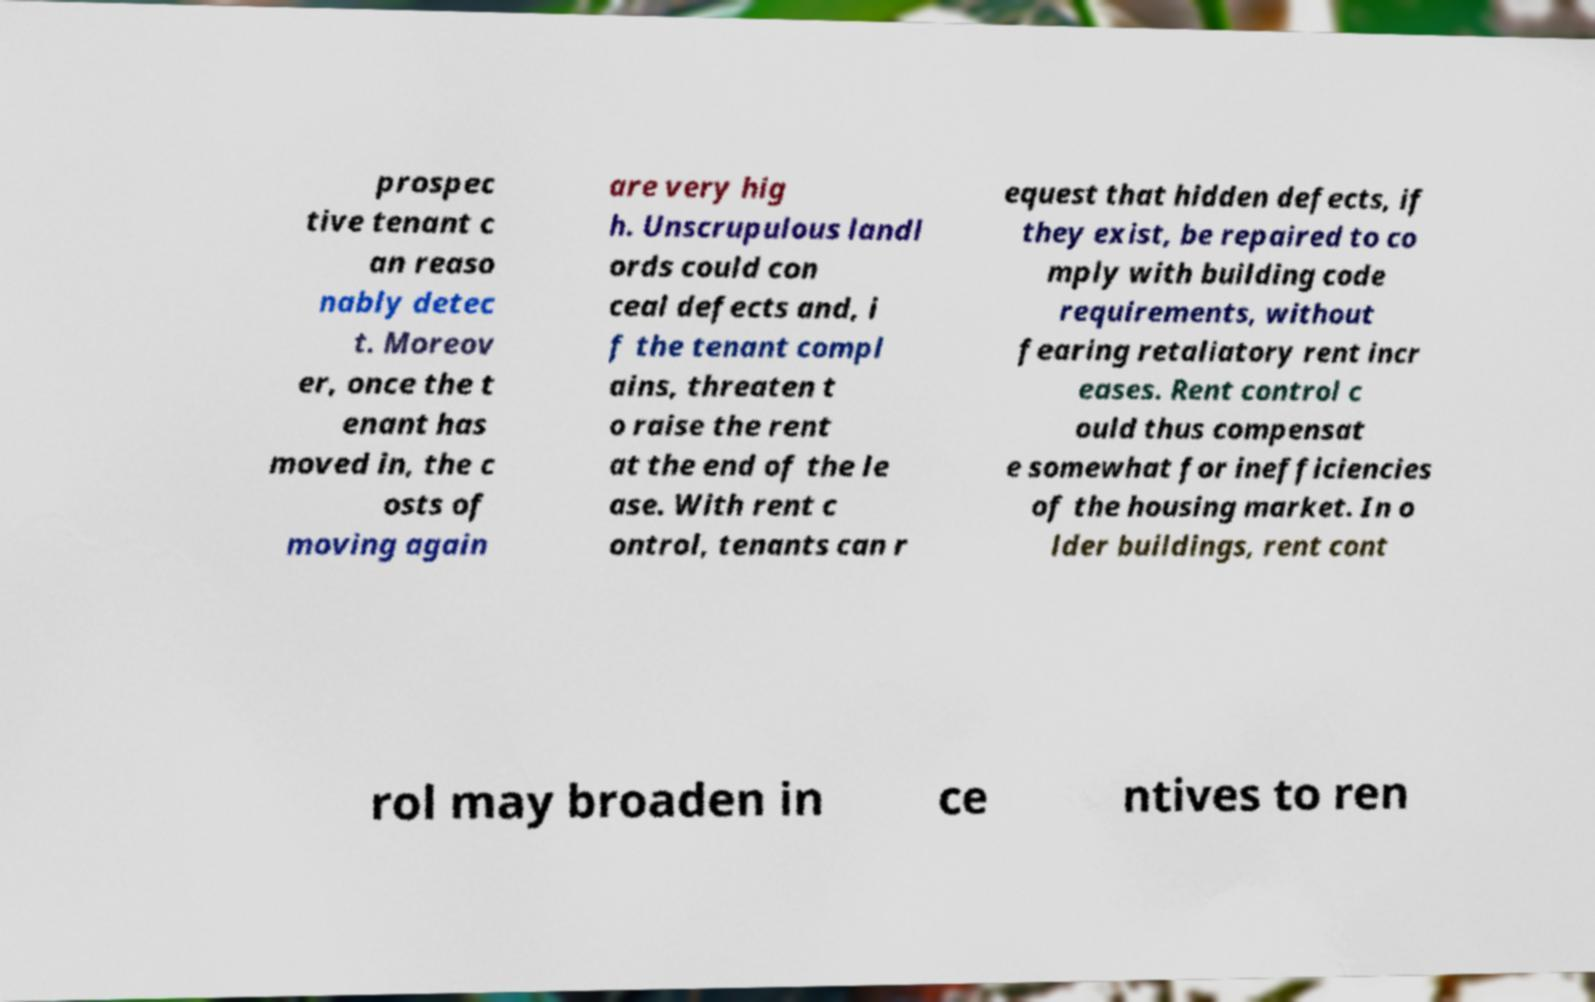Can you read and provide the text displayed in the image?This photo seems to have some interesting text. Can you extract and type it out for me? prospec tive tenant c an reaso nably detec t. Moreov er, once the t enant has moved in, the c osts of moving again are very hig h. Unscrupulous landl ords could con ceal defects and, i f the tenant compl ains, threaten t o raise the rent at the end of the le ase. With rent c ontrol, tenants can r equest that hidden defects, if they exist, be repaired to co mply with building code requirements, without fearing retaliatory rent incr eases. Rent control c ould thus compensat e somewhat for inefficiencies of the housing market. In o lder buildings, rent cont rol may broaden in ce ntives to ren 